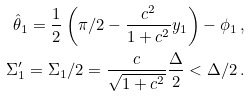Convert formula to latex. <formula><loc_0><loc_0><loc_500><loc_500>\hat { \theta } _ { 1 } = \frac { 1 } { 2 } \left ( \pi / 2 - \frac { c ^ { 2 } } { 1 + c ^ { 2 } } y _ { 1 } \right ) - \phi _ { 1 } \, , \\ \Sigma _ { 1 } ^ { \prime } = \Sigma _ { 1 } / 2 = \frac { c } { \sqrt { 1 + c ^ { 2 } } } \frac { \Delta } { 2 } < \Delta / 2 \, .</formula> 